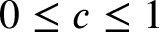Convert formula to latex. <formula><loc_0><loc_0><loc_500><loc_500>0 \leq c \leq 1</formula> 